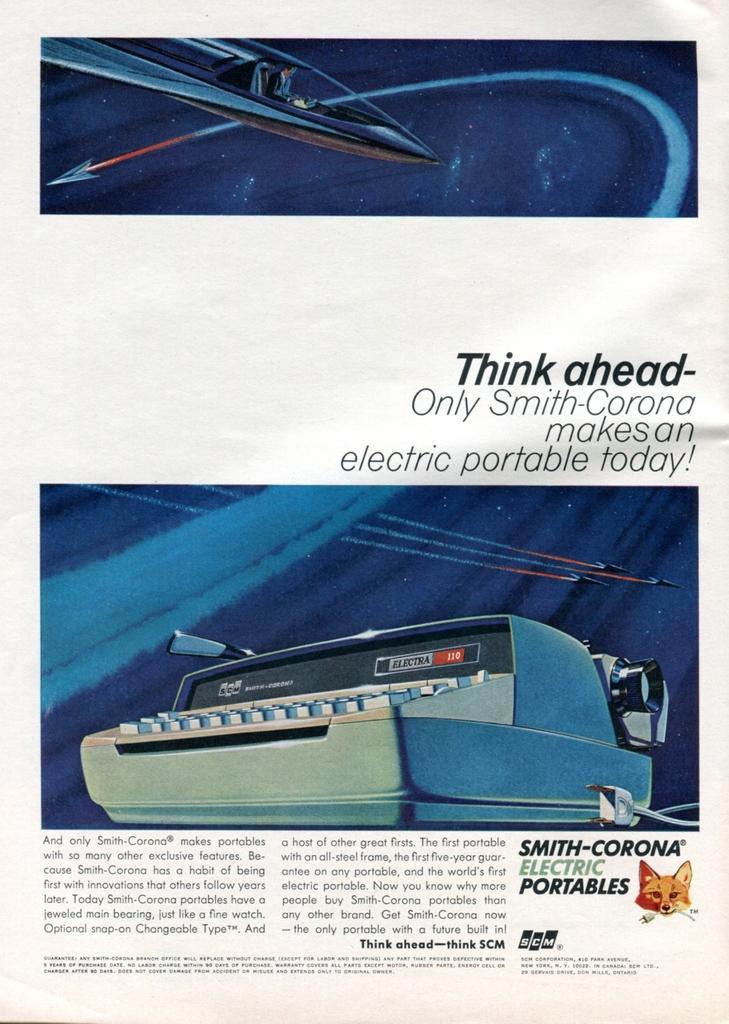In one or two sentences, can you explain what this image depicts? In this image I can see an article on a paper in which I can see 2 images in which I can see an object which is white and black in color and another metal object. I can see a fox head and few words written in the article. 